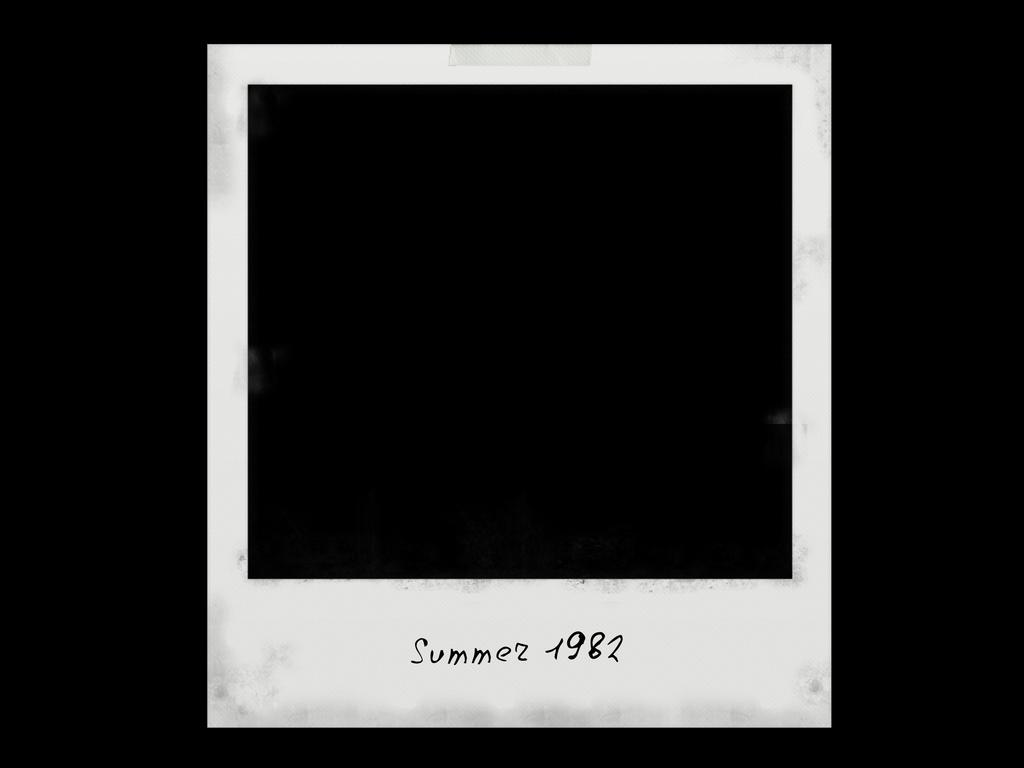<image>
Offer a succinct explanation of the picture presented. A completely black Polaroid picture from the summer of 1982. 